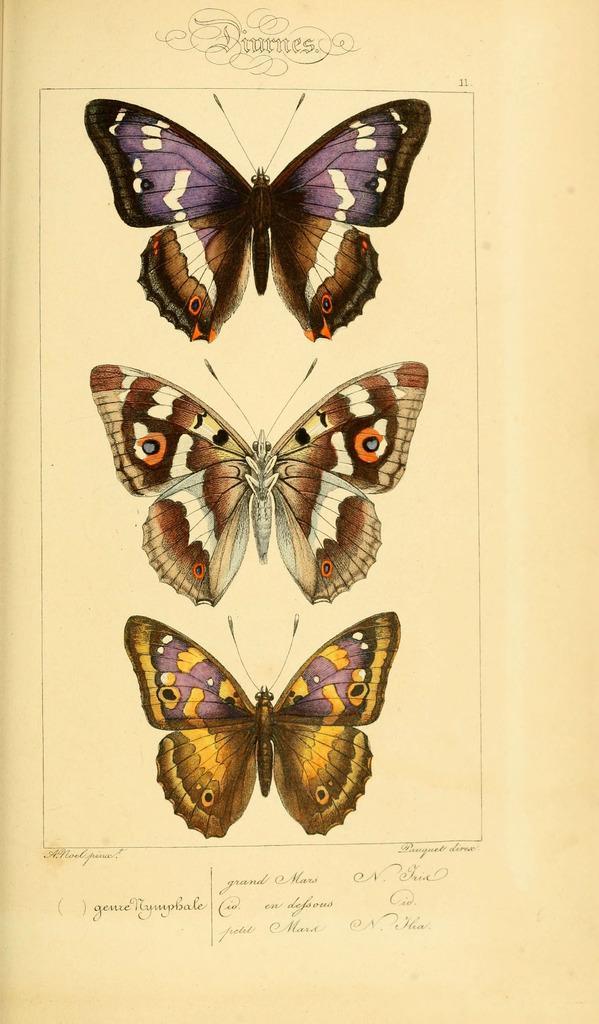Describe this image in one or two sentences. In the center of this picture we can see the printed images of butterflies of different colors and we can see the text on the object which seems to be the paper. 